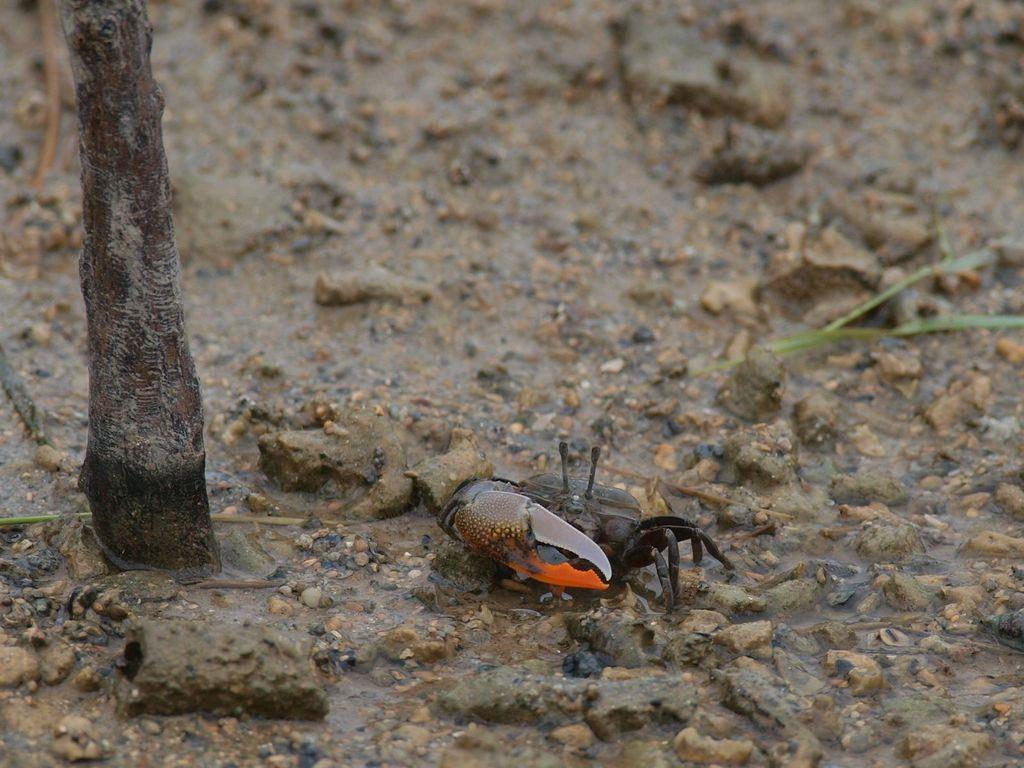What type of creature can be seen in the picture? There is an insect in the picture. What natural object is present in the picture? There is a tree trunk in the picture. What type of inanimate objects can be seen in the picture? There are stones in the picture. What type of bird is perched on the sofa in the image? There is no sofa or bird present in the image; it features an insect and a tree trunk. How many worms can be seen crawling on the stones in the image? There are no worms present in the image; it only features an insect, a tree trunk, and stones. 